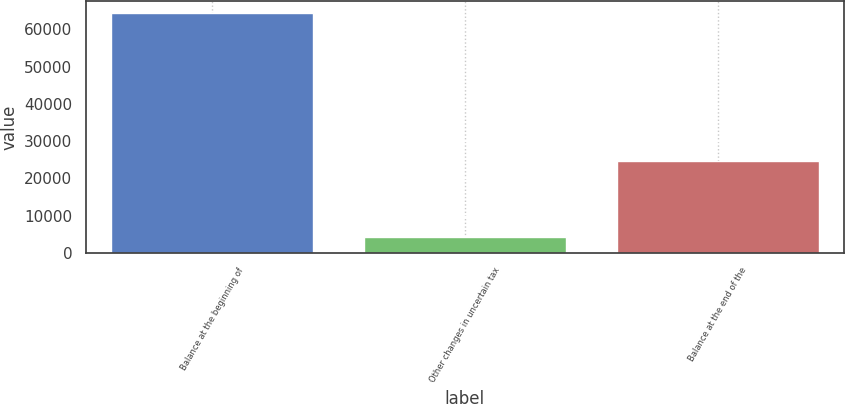Convert chart. <chart><loc_0><loc_0><loc_500><loc_500><bar_chart><fcel>Balance at the beginning of<fcel>Other changes in uncertain tax<fcel>Balance at the end of the<nl><fcel>64390<fcel>4395<fcel>24716<nl></chart> 